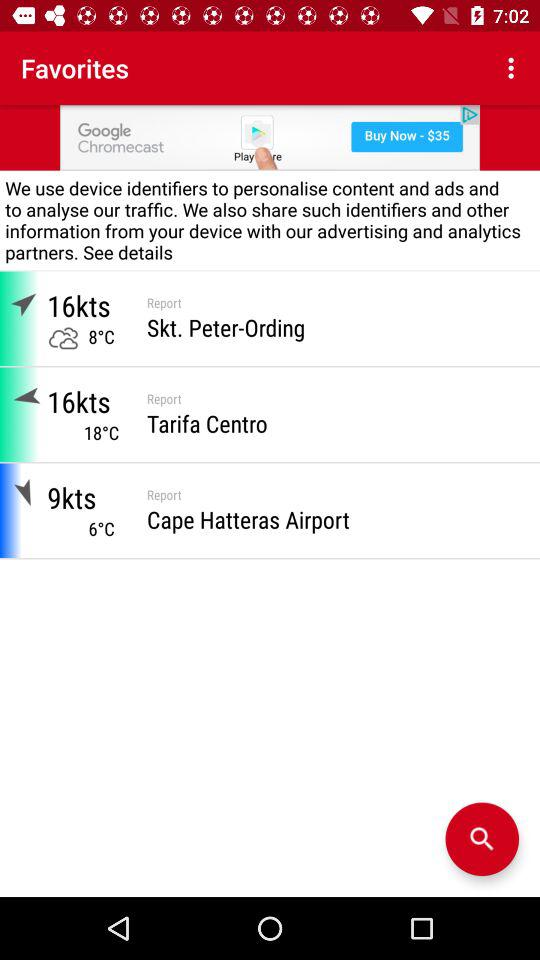How many degrees colder is the temperature in Cape Hatteras Airport than in Skt. Peter-Ording?
Answer the question using a single word or phrase. 2 